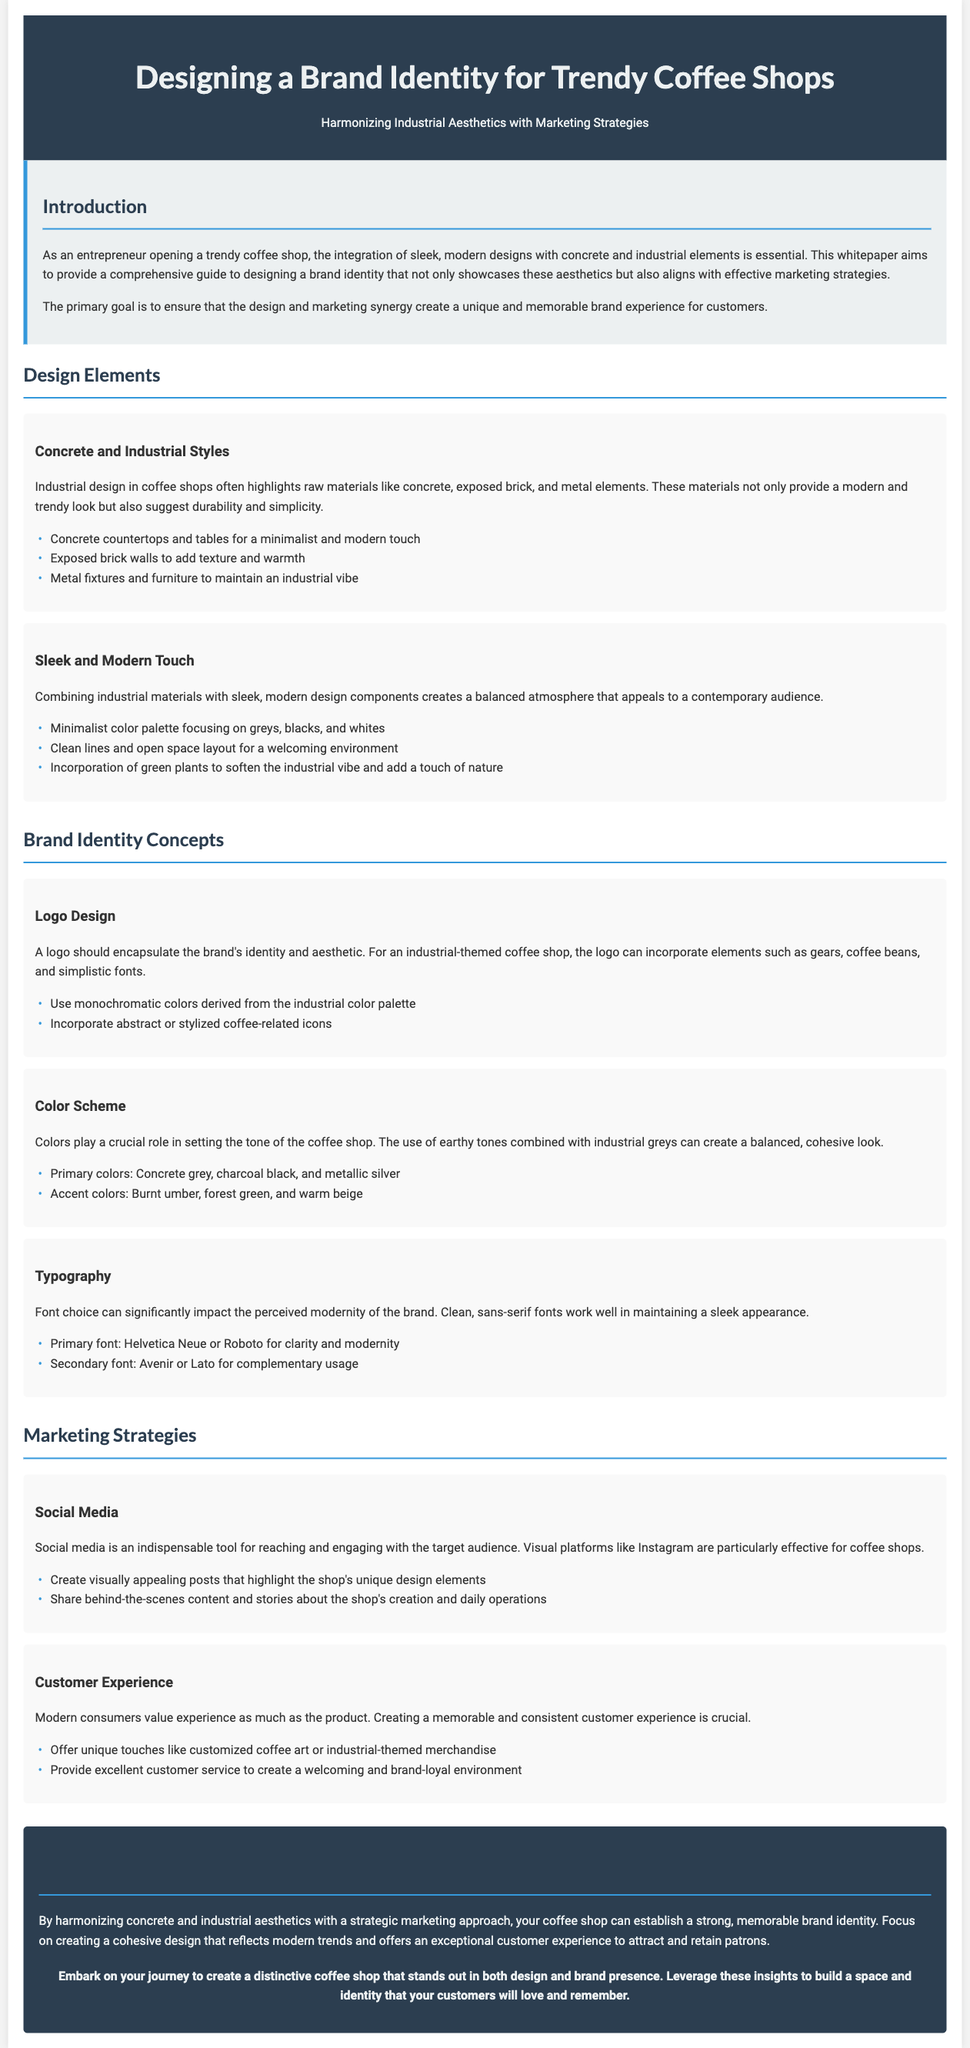what is the title of the whitepaper? The title is presented prominently at the top of the document, introducing the subject it covers.
Answer: Designing a Brand Identity for Trendy Coffee Shops: Harmonizing Industrial Aesthetics with Marketing Strategies what is highlighted as a key design element for coffee shops? The document mentions specific materials and designs essential for creating the desired aesthetics in coffee shops.
Answer: Concrete and Industrial Styles which color is suggested as a primary color for the coffee shop's design? The document outlines a color scheme, specifying certain colors that align with the brand's modern aesthetic.
Answer: Concrete grey what font is recommended for clarity and modernity? The typography section refers to specific fonts that are suitable for embodying a sleek appearance in brand identity.
Answer: Helvetica Neue what marketing strategy is deemed crucial for engaging the target audience? The document identifies various methods for promoting the coffee shop, with an emphasis on a specific strategy that stands out.
Answer: Social Media how many design elements are listed in the document? By reviewing the sections regarding design elements, the total number of specific elements can be counted.
Answer: Six what unique customer experience suggestion is mentioned? The document provides insights into enhancing customer experience, suggesting innovative ideas that align with brand identity.
Answer: Customized coffee art what is the primary goal outlined in the introduction? The introduction describes the main objective of the document, summarizing the overarching aim of creating a brand experience.
Answer: Unique and memorable brand experience what is the color of the conclusion section's background? The document describes the colors used for different sections, including the conclusion, specifying the background's color.
Answer: Dark blue 